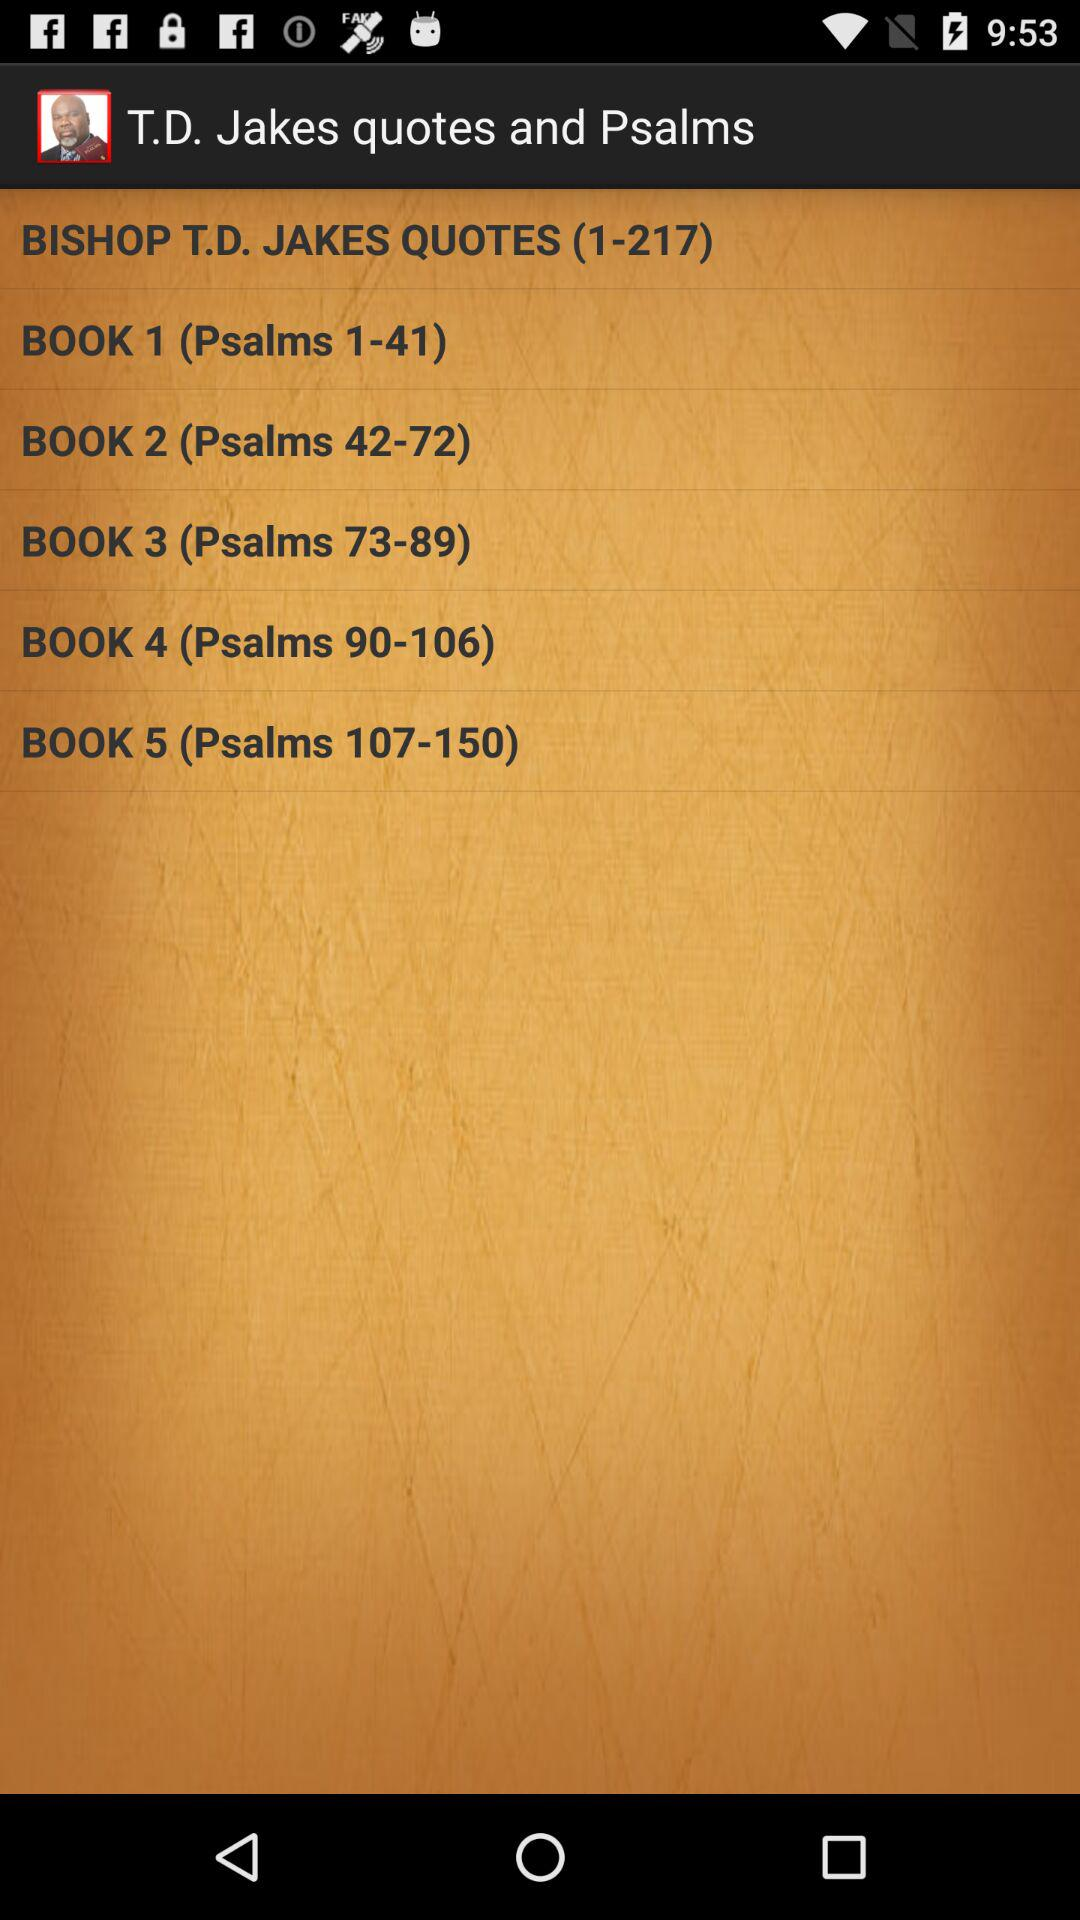How many more books are in the Psalms section than in the T.D. Jakes Quotes section?
Answer the question using a single word or phrase. 4 